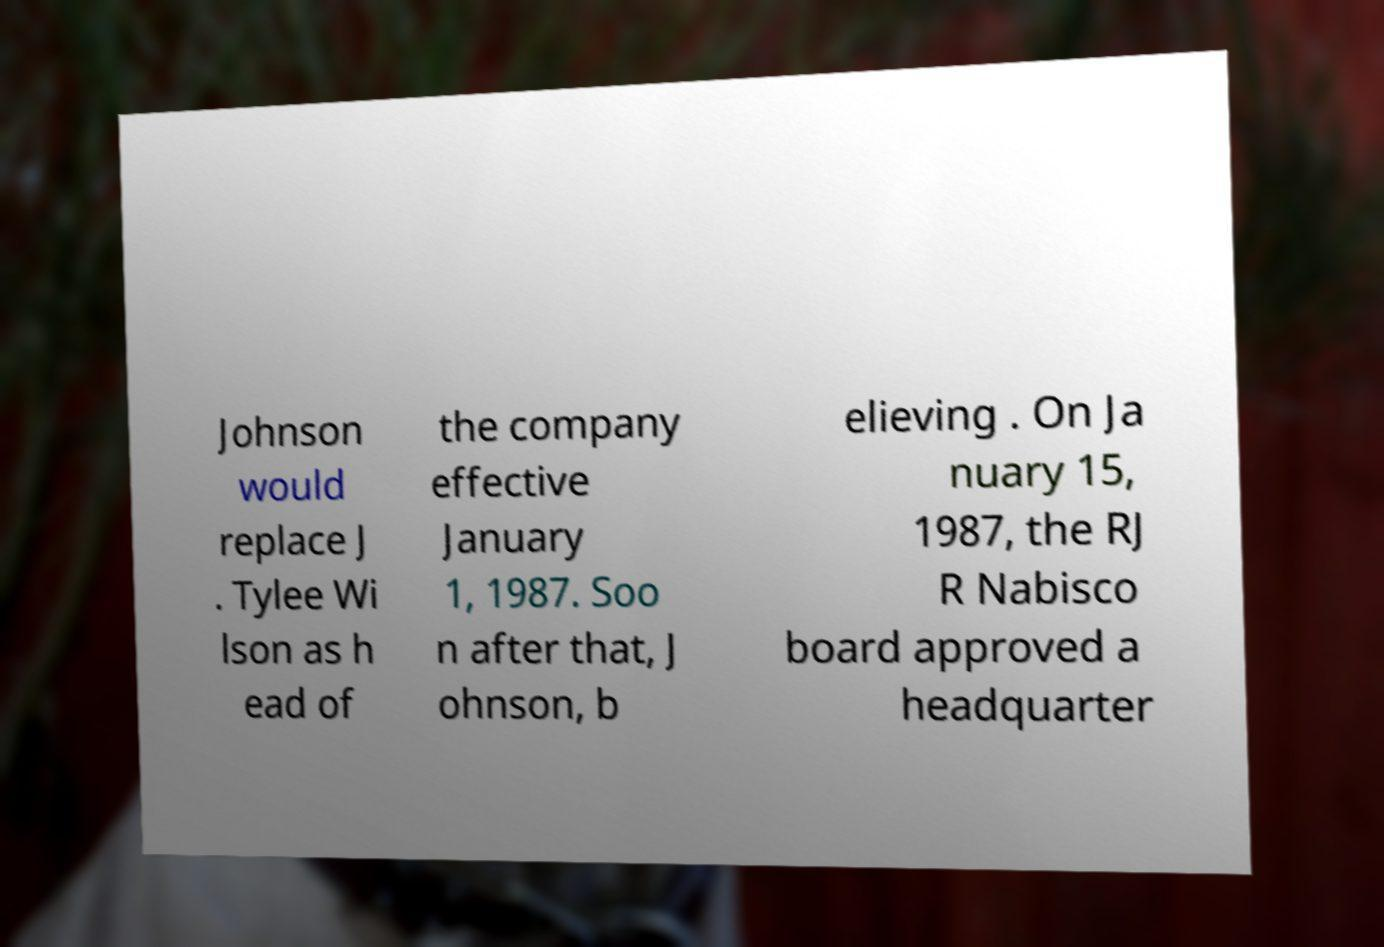I need the written content from this picture converted into text. Can you do that? Johnson would replace J . Tylee Wi lson as h ead of the company effective January 1, 1987. Soo n after that, J ohnson, b elieving . On Ja nuary 15, 1987, the RJ R Nabisco board approved a headquarter 